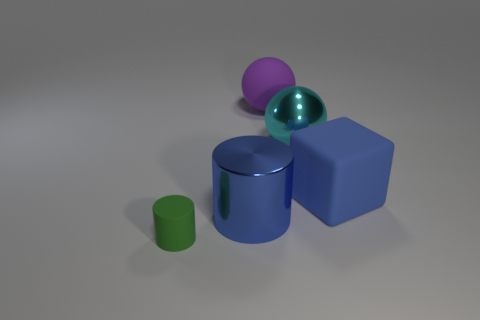Add 2 large purple spheres. How many objects exist? 7 Subtract all cubes. How many objects are left? 4 Subtract all big metal cylinders. Subtract all blue metal cylinders. How many objects are left? 3 Add 5 green matte things. How many green matte things are left? 6 Add 1 blue shiny objects. How many blue shiny objects exist? 2 Subtract 0 purple cylinders. How many objects are left? 5 